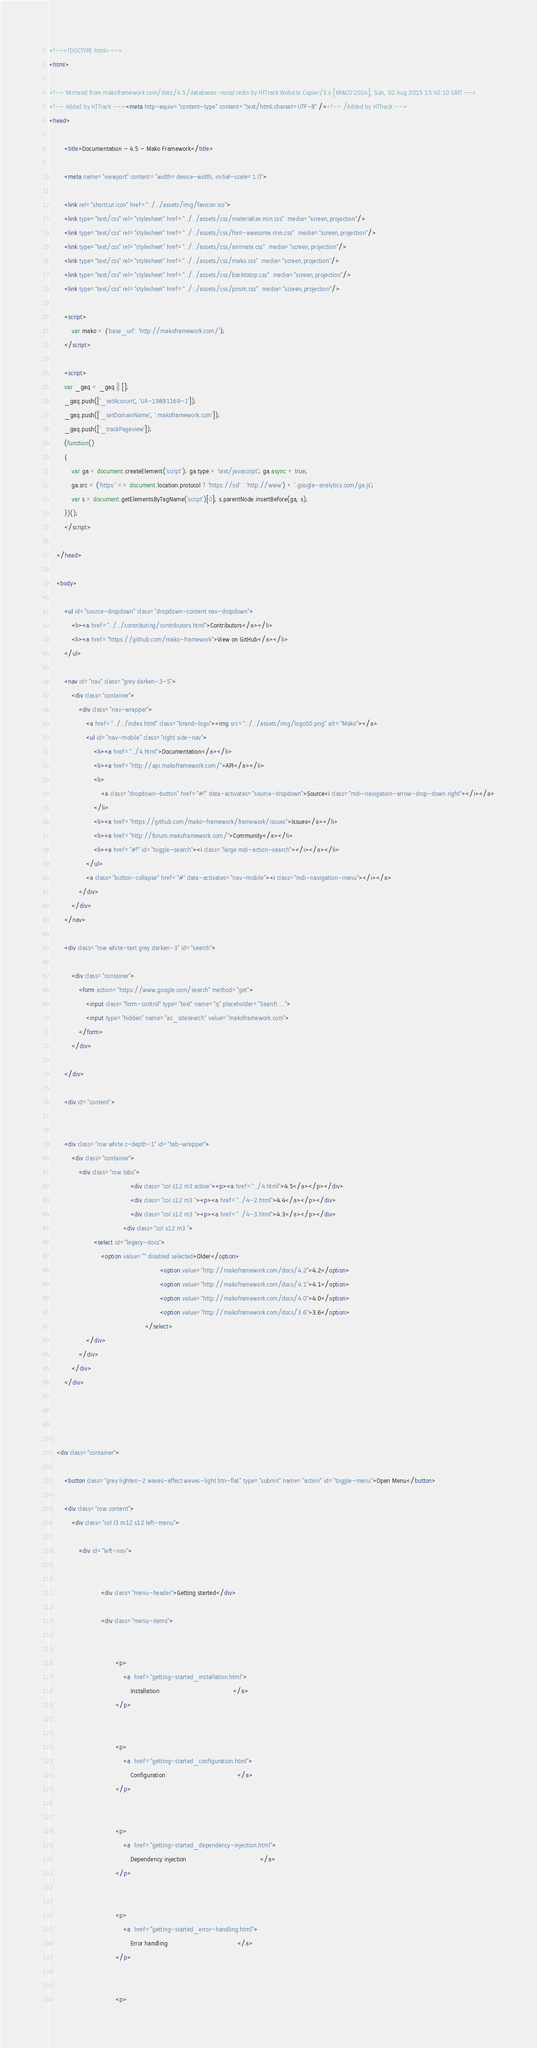<code> <loc_0><loc_0><loc_500><loc_500><_HTML_>


<!--<!DOCTYPE html>-->
<html>
	
<!-- Mirrored from makoframework.com/docs/4.5/databases-nosql:redis by HTTrack Website Copier/3.x [XR&CO'2014], Sun, 02 Aug 2015 15:42:10 GMT -->
<!-- Added by HTTrack --><meta http-equiv="content-type" content="text/html;charset=UTF-8" /><!-- /Added by HTTrack -->
<head>

		<title>Documentation - 4.5 - Mako Framework</title>

		<meta name="viewport" content="width=device-width, initial-scale=1.0">

		<link rel="shortcut icon" href="../../assets/img/favicon.ico">
		<link type="text/css" rel="stylesheet" href="../../assets/css/materialize.min.css"  media="screen,projection"/>
		<link type="text/css" rel="stylesheet" href="../../assets/css/font-awesome.min.css"  media="screen,projection"/>
		<link type="text/css" rel="stylesheet" href="../../assets/css/animate.css"  media="screen,projection"/>
		<link type="text/css" rel="stylesheet" href="../../assets/css/mako.css"  media="screen,projection"/>
		<link type="text/css" rel="stylesheet" href="../../assets/css/backtotop.css"  media="screen,projection"/>
		<link type="text/css" rel="stylesheet" href="../../assets/css/prism.css"  media="screen,projection"/>

		<script>
			var mako = {'base_url': 'http://makoframework.com/'};
		</script>

		<script>
		var _gaq = _gaq || [];
		_gaq.push(['_setAccount', 'UA-19891169-1']);
		_gaq.push(['_setDomainName', '.makoframework.com']);
		_gaq.push(['_trackPageview']);
		(function()
		{
			var ga = document.createElement('script'); ga.type = 'text/javascript'; ga.async = true;
			ga.src = ('https:' == document.location.protocol ? 'https://ssl' : 'http://www') + '.google-analytics.com/ga.js';
			var s = document.getElementsByTagName('script')[0]; s.parentNode.insertBefore(ga, s);
		})();
		</script>

	</head>

	<body>

		<ul id="source-dropdown" class="dropdown-content nav-dropdown">
			<li><a href="../../contributing/contributors.html">Contributors</a></li>
			<li><a href="https://github.com/mako-framework">View on GitHub</a></li>
		</ul>

		<nav id="nav" class="grey darken-3-5">
			<div class="container">
				<div class="nav-wrapper">
					<a href="../../index.html" class="brand-logo"><img src="../../assets/img/logo50.png" alt="Mako"></a>
					<ul id="nav-mobile" class="right side-nav">
						<li><a href="../4.html">Documentation</a></li>
						<li><a href="http://api.makoframework.com/">API</a></li>
						<li>
							<a class="dropdown-button" href="#!" data-activates="source-dropdown">Source<i class="mdi-navigation-arrow-drop-down right"></i></a>
						</li>
						<li><a href="https://github.com/mako-framework/framework/issues">Issues</a></li>
						<li><a href="http://forum.makoframework.com/">Community</a></li>
						<li><a href="#!" id="toggle-search"><i class="large mdi-action-search"></i></a></li>
					</ul>
					<a class="button-collapse" href="#" data-activates="nav-mobile"><i class="mdi-navigation-menu"></i></a>
				</div>
			</div>
		</nav>

		<div class="row white-text grey darken-3" id="search">

			<div class="container">
				<form action="https://www.google.com/search" method="get">
					<input class="form-control" type="text" name="q" placeholder="Search ...">
					<input type="hidden" name="as_sitesearch" value="makoframework.com">
				</form>
			</div>

		</div>

		<div id="content">

			
		<div class="row white z-depth-1" id="tab-wrapper">
			<div class="container">
				<div class="row tabs">
											<div class="col s12 m3 active"><p><a href="../4.html">4.5</a></p></div>
											<div class="col s12 m3 "><p><a href="../4-2.html">4.4</a></p></div>
											<div class="col s12 m3 "><p><a href="../4-3.html">4.3</a></p></div>
										<div class="col s12 m3 ">
						<select id="legacy-docs">
							<option value="" disabled selected>Older</option>
															<option value="http://makoframework.com/docs/4.2">4.2</option>
															<option value="http://makoframework.com/docs/4.1">4.1</option>
															<option value="http://makoframework.com/docs/4.0">4.0</option>
															<option value="http://makoframework.com/docs/3.6">3.6</option>
													</select>
					</div>
				</div>
			</div>
		</div>



			
	<div class="container">

		<button class="grey lighten-2 waves-effect waves-light btn-flat" type="submit" name="action" id="toggle-menu">Open Menu</button>

		<div class="row content">
			<div class="col l3 m12 s12 left-menu">

				<div id="left-nav">
				
					
							<div class="menu-header">Getting started</div>

							<div class="menu-items">

								
									<p>
										<a  href="getting-started_installation.html">
											Installation										</a>
									</p>

								
									<p>
										<a  href="getting-started_configuration.html">
											Configuration										</a>
									</p>

								
									<p>
										<a  href="getting-started_dependency-injection.html">
											Dependency injection										</a>
									</p>

								
									<p>
										<a  href="getting-started_error-handling.html">
											Error handling										</a>
									</p>

								
									<p></code> 